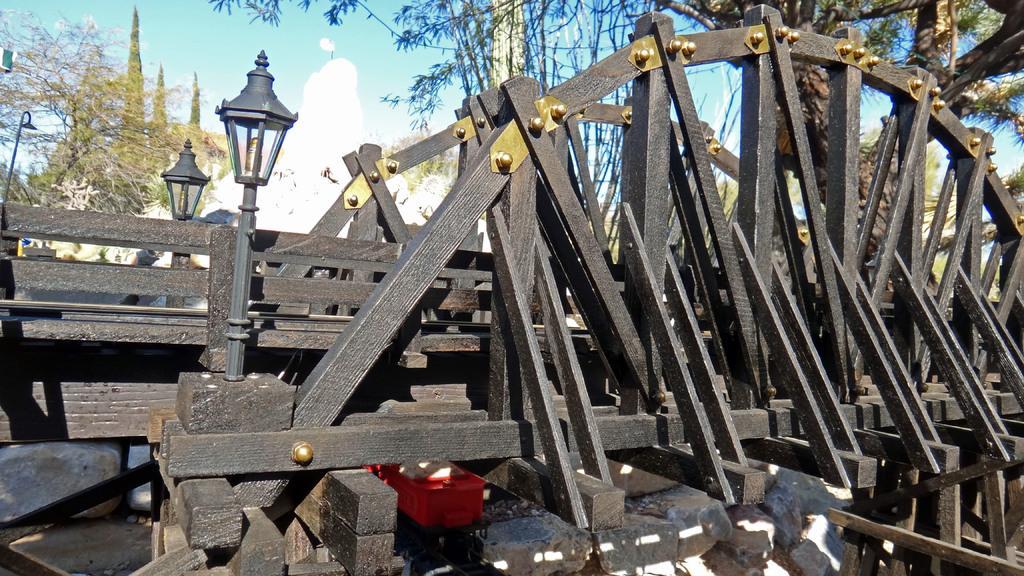Can you describe this image briefly? In this image, we can see a wooden bridge and there are lights. In the background, there are trees. At the top, there are clouds in the sky. 